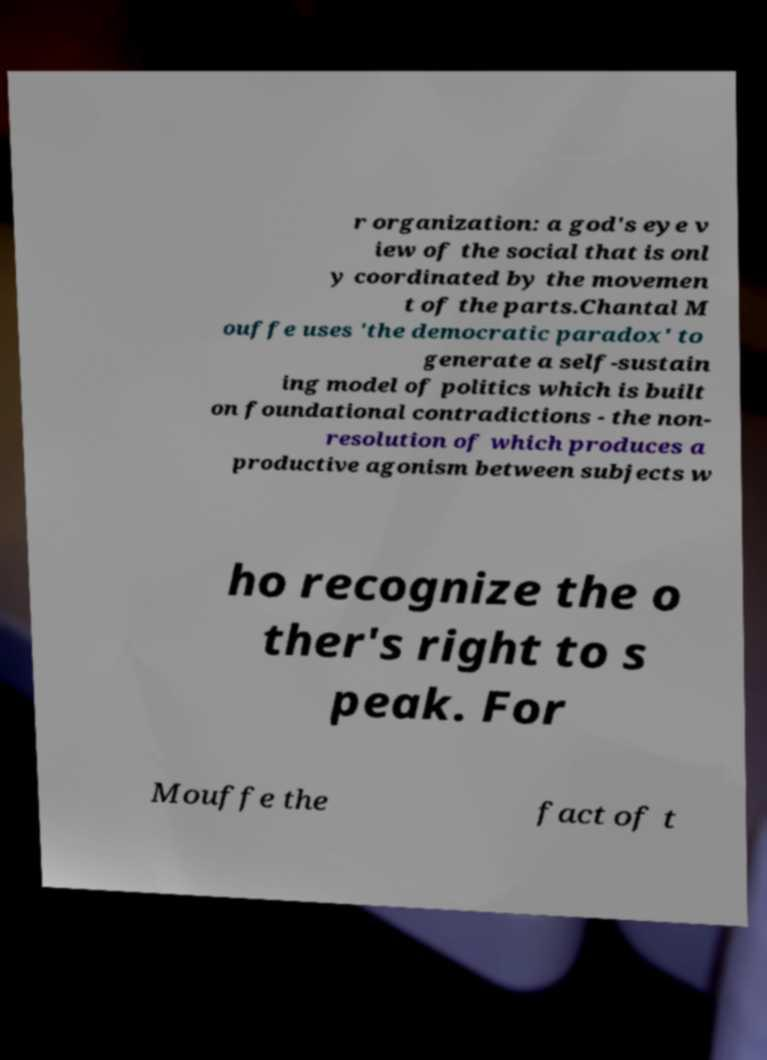Please identify and transcribe the text found in this image. r organization: a god's eye v iew of the social that is onl y coordinated by the movemen t of the parts.Chantal M ouffe uses 'the democratic paradox' to generate a self-sustain ing model of politics which is built on foundational contradictions - the non- resolution of which produces a productive agonism between subjects w ho recognize the o ther's right to s peak. For Mouffe the fact of t 